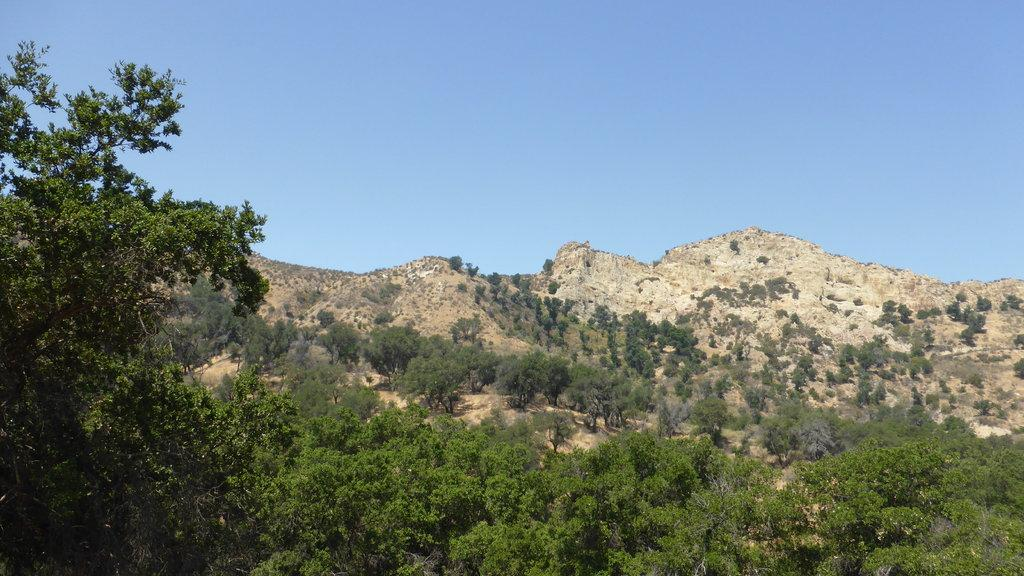What type of landscape is depicted in the image? The image features hills and many trees. What can be seen at the top of the image? The sky is visible at the top of the image. Can you see any snakes slithering among the trees in the image? There are no snakes present in the image; it features hills and trees with a visible sky. 